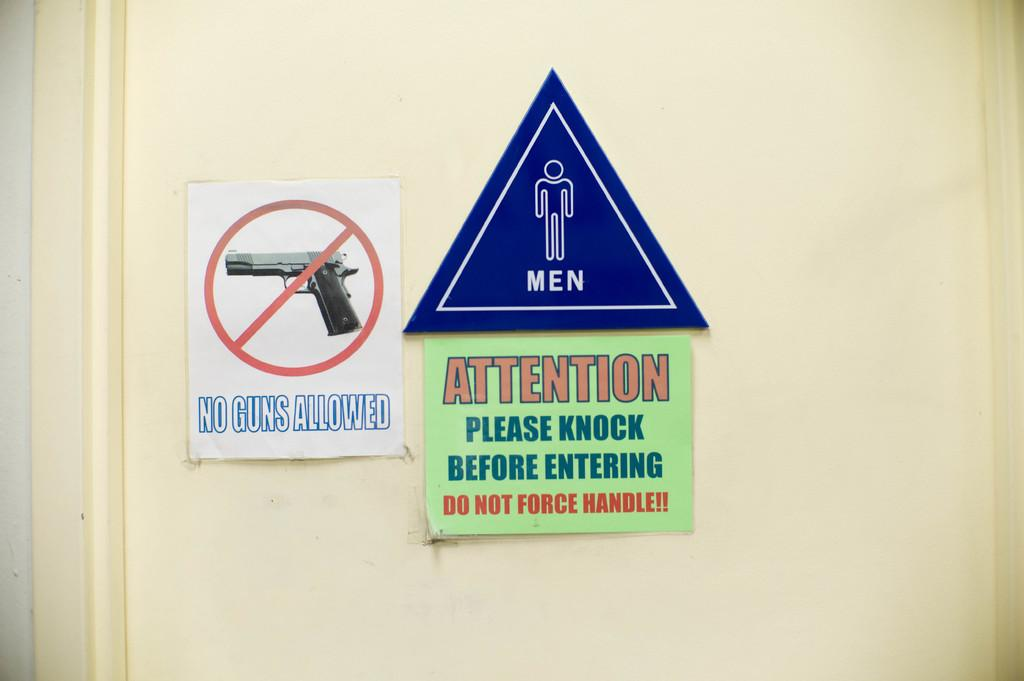What can be found in the front of the image? There is a door in the front of the image. What is the purpose of the caution boards on the door? The many caution boards on the door indicate that there may be a need for caution or warning. Can you describe the door in the image? The door is in the front and has multiple caution boards on it. What type of bag is hanging from the door in the image? There is no bag hanging from the door in the image; it only has caution boards. 